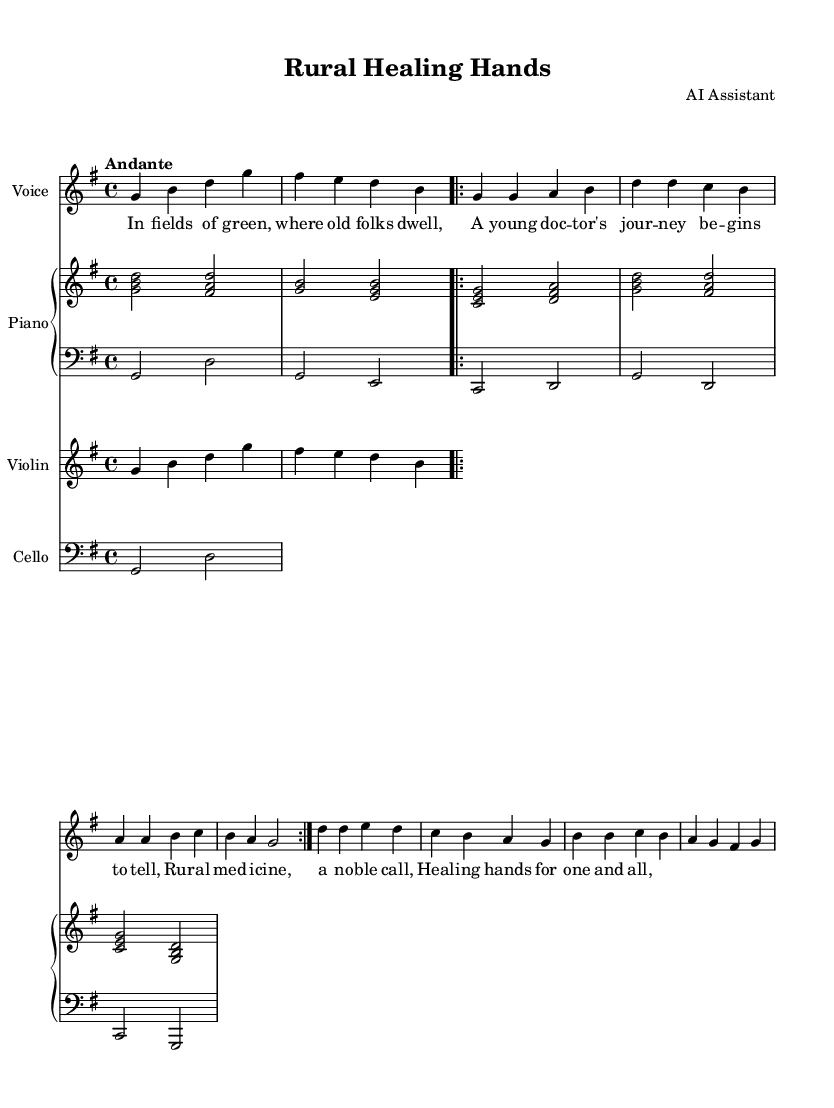What is the key signature of this music? The key signature is G major, which has one sharp (F#). This can be identified from the key signature marking at the beginning of the staff.
Answer: G major What is the time signature of this piece? The time signature is four-four, indicated at the beginning with a "4/4". This shows that there are four beats per measure.
Answer: Four-four What is the tempo marking for this piece? The tempo marking is "Andante", which suggests a moderate tempo. This is typically indicated at the beginning of the score, providing guidance on the speed of the music.
Answer: Andante What instruments are written in this opera? The instruments include Voice, Piano, Violin, and Cello. Each of these is labeled at the beginning of the respective staff.
Answer: Voice, Piano, Violin, Cello How many times is the first verse repeated? The first verse is repeated twice, which is indicated by the "repeat volta 2" notation in the soprano part. This notation shows that the section should be played again.
Answer: Two times What is the first line of the lyrics? The first line of the lyrics is "In fields of green, where old folks dwell," as seen in the lyrics section aligned with the music notes.
Answer: In fields of green, where old folks dwell What is the primary theme of this opera as reflected in the lyrics? The primary theme revolves around rural medicine and the journey of a young doctor, as suggested by key phrases in the lyrics such as "young doctor" and "rural medicine".
Answer: Rural medicine 